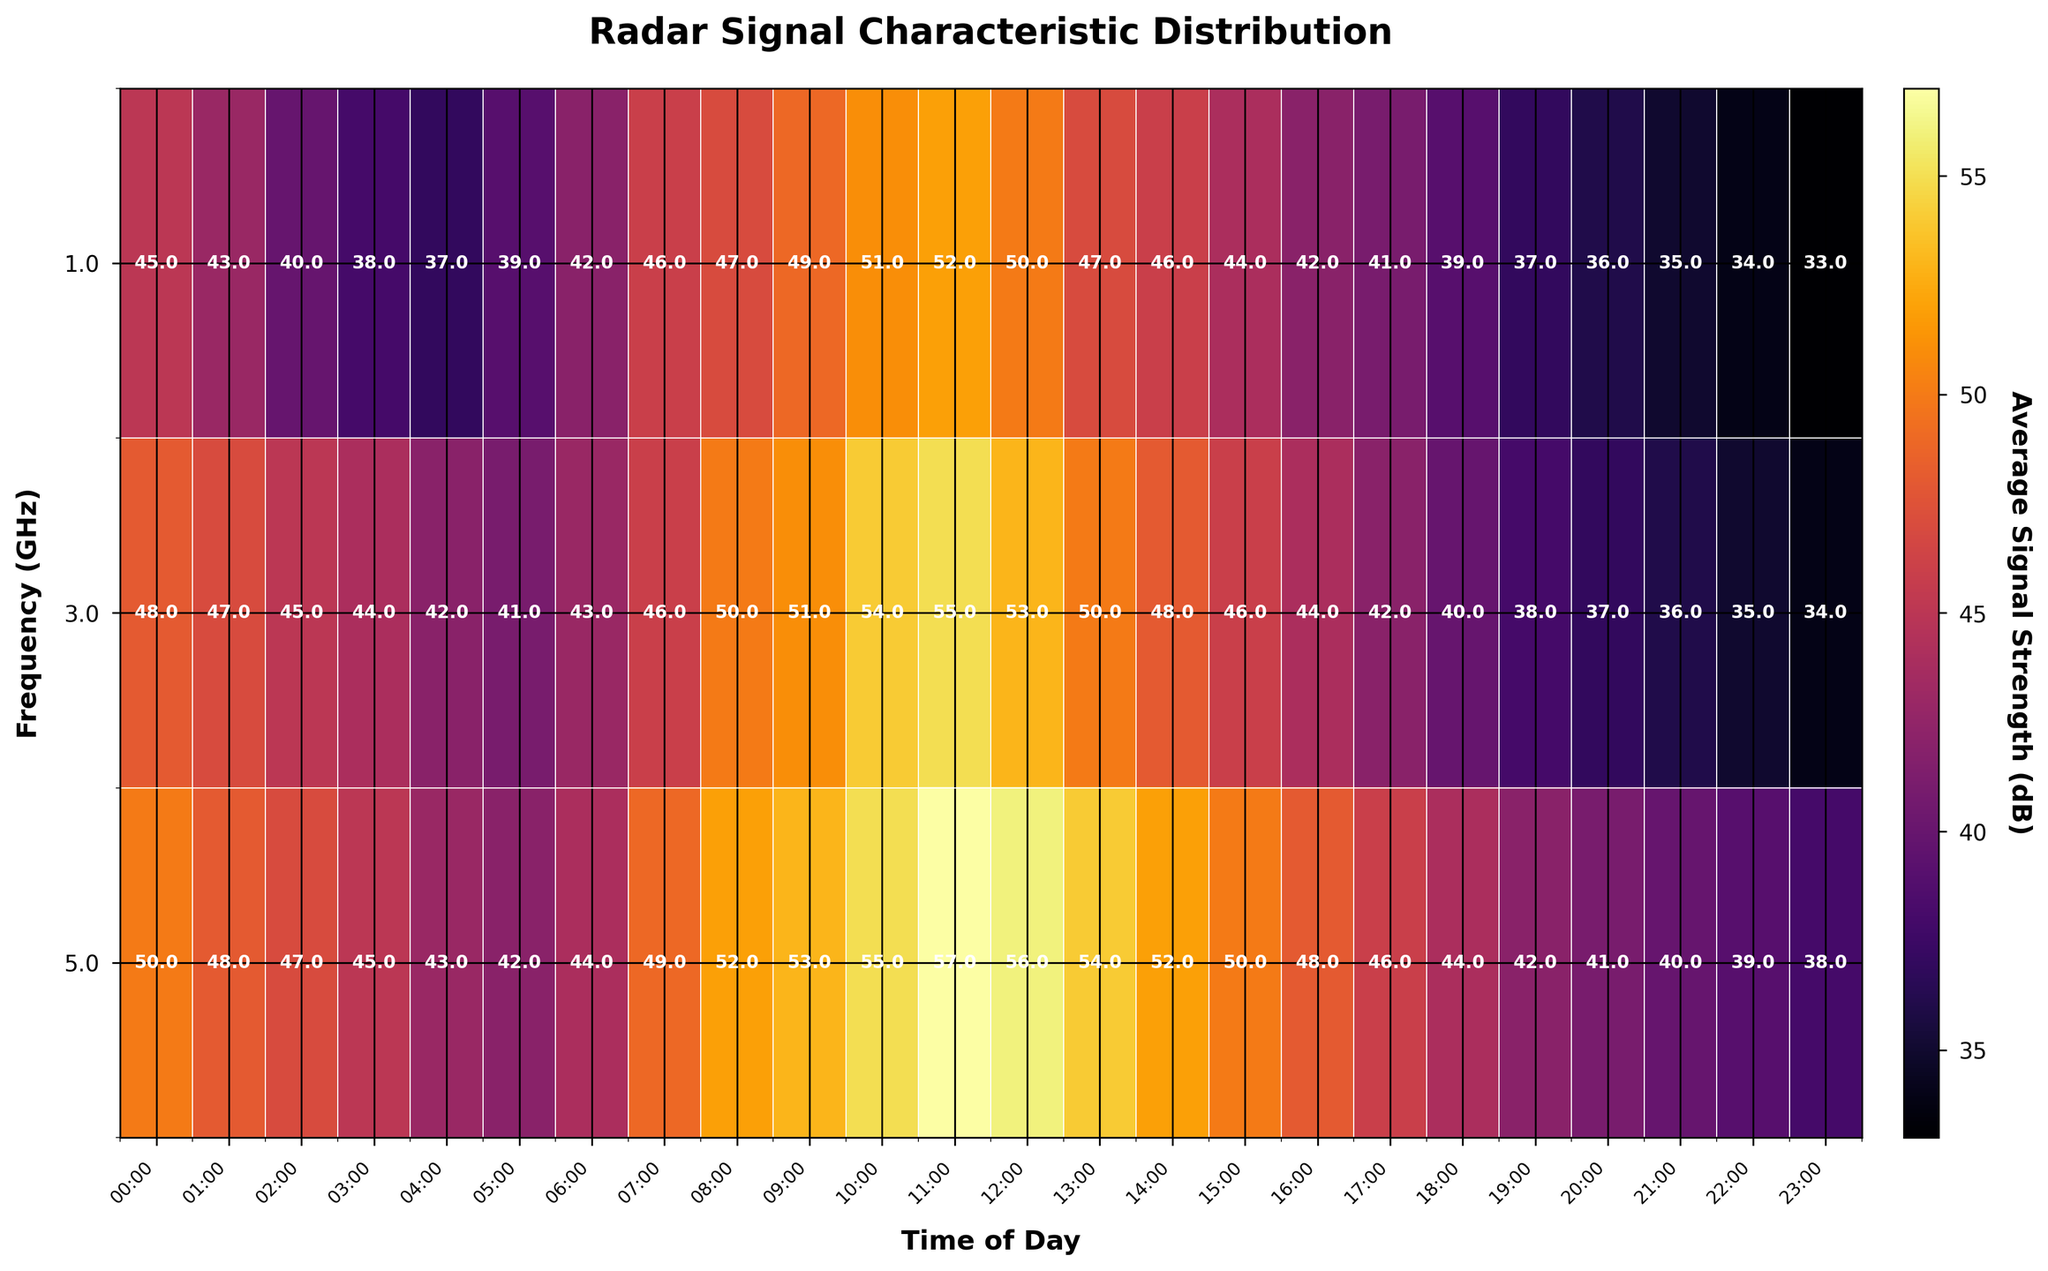What's the title of the figure? The title is usually located at the top of the figure, and in this case, it is "Radar Signal Characteristic Distribution".
Answer: Radar Signal Characteristic Distribution What does the color bar on the right represent? The color bar provides a scale that indicates the range of values represented by different colors in the heatmap. Here, it is labeled "Average Signal Strength (dB)" and shows how signal strength varies across the heatmap.
Answer: Average Signal Strength (dB) At what time of day does the frequency of 5.0 GHz have its maximum signal strength? To determine this, look at the row corresponding to the frequency of 5.0 GHz and identify the time of day with the darkest shade on the color scale. The darkest shade corresponds to the highest dB value, which is at 11:00.
Answer: 11:00 Which frequency shows the greatest variation in signal strength throughout the day? To answer this, compare the range of signal strengths (from the darkest to the lightest color) for each frequency row. The frequency of 5.0 GHz shows a significant change in color intensity from midnight to the end of the day.
Answer: 5.0 GHz How does the signal strength at 1.0 GHz compare between 06:00 and 18:00? Refer to the row for 1.0 GHz and compare the values at the corresponding columns for 06:00 (42 dB) and 18:00 (39 dB). 42 dB is greater than 39 dB, so the signal strength is higher at 06:00.
Answer: Higher at 06:00 What is the signal strength at 3.0 GHz at midday (12:00)? To find this, look at the row for 3.0 GHz and the column for 12:00. The intersection shows a value of 53 dB.
Answer: 53 dB How much does the signal strength at 1.0 GHz decrease from 09:00 to 23:00? The signal strength at 09:00 is 49 dB and at 23:00 is 33 dB. The difference is 49 dB - 33 dB, which equates to a decrease of 16 dB.
Answer: 16 dB Which time of day generally shows the highest signal strengths across all frequencies? To answer this, examine the color intensities for each time of day column across the heatmap. Around late morning to early afternoon (11:00 to 12:00) generally shows the highest signal strengths, indicating darker shades across all frequencies.
Answer: 11:00 to 12:00 Does the signal strength at 5.0 GHz ever drop below 40 dB? Scan the values in the row for 5.0 GHz. At 20:00, 21:00, 22:00, and 23:00, the signal strengths are 41 dB, 40 dB, 39 dB, and 38 dB respectively, which means it does drop below 40 dB before midnight.
Answer: Yes What are the time periods with the lowest signal strength at 3.0 GHz? For this, look at the row corresponding to 3.0 GHz and identify the lightest shades, which are at 22:00, 23:00, and 00:00 with values of 35 dB, 34 dB, and 48 dB respectively, indicating low signal strength.
Answer: 22:00-00:00 